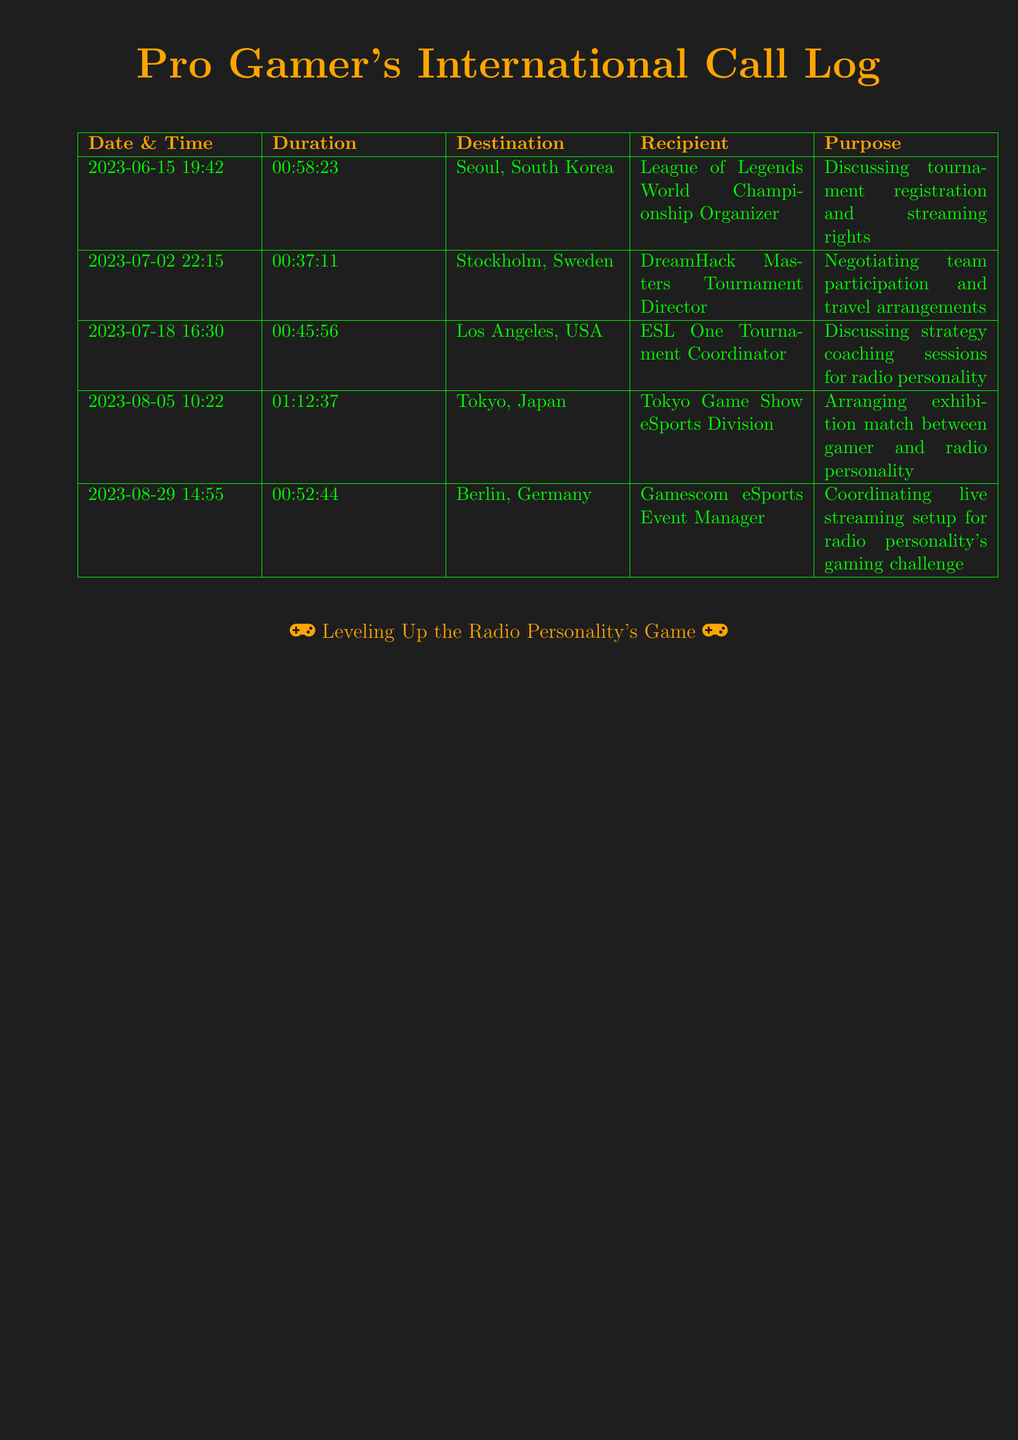What is the date of the call with the ESL One Tournament Coordinator? The call with the ESL One Tournament Coordinator occurred on July 18, 2023.
Answer: July 18, 2023 How long was the call to discuss tournament registration with the League of Legends World Championship Organizer? The duration of the call discussing tournament registration was 58 minutes and 23 seconds.
Answer: 00:58:23 Which city was the call to arrange an exhibition match located? The call to arrange an exhibition match was directed to Tokyo.
Answer: Tokyo Who was the recipient of the call regarding the live streaming setup? The recipient of the call regarding live streaming setup was the Gamescom eSports Event Manager.
Answer: Gamescom eSports Event Manager What was the main purpose of the call on August 5th? The main purpose of the call on August 5th was to arrange an exhibition match.
Answer: Arranging exhibition match Which tournament director was contacted on July 2nd? The tournament director contacted on July 2nd was the DreamHack Masters Tournament Director.
Answer: DreamHack Masters Tournament Director What is the total duration of the call with Tokyo Game Show eSports Division? The total duration of the call with Tokyo Game Show eSports Division was one hour, twelve minutes, and thirty-seven seconds.
Answer: 01:12:37 How many international calls related to gaming tournaments are logged? There are five international calls related to gaming tournaments logged in the document.
Answer: Five 